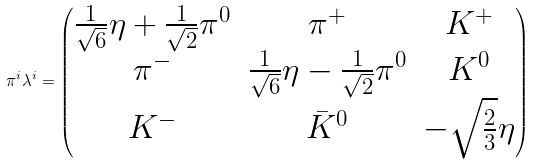Convert formula to latex. <formula><loc_0><loc_0><loc_500><loc_500>\pi ^ { i } \lambda ^ { i } = \begin{pmatrix} \frac { 1 } { \sqrt { 6 } } \eta + \frac { 1 } { \sqrt { 2 } } \pi ^ { 0 } & \pi ^ { + } & K ^ { + } \\ \pi ^ { - } & \frac { 1 } { \sqrt { 6 } } \eta - \frac { 1 } { \sqrt { 2 } } \pi ^ { 0 } & K ^ { 0 } \\ K ^ { - } & \bar { K } ^ { 0 } & - \sqrt { \frac { 2 } { 3 } } \eta \end{pmatrix}</formula> 